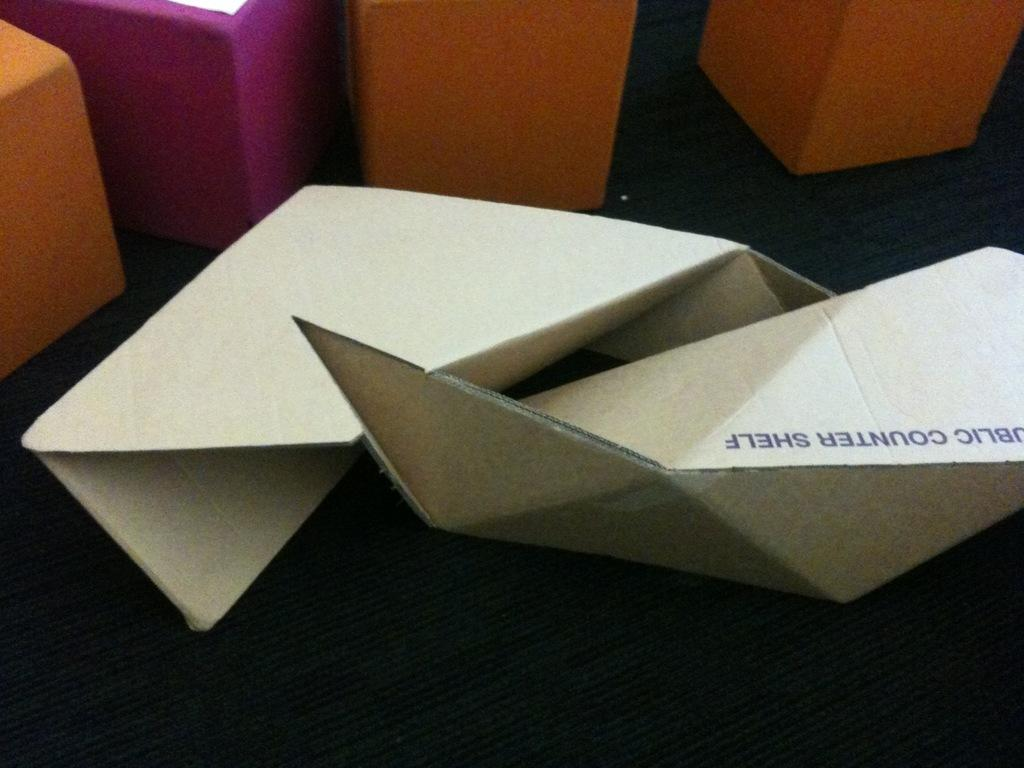What type of objects can be seen in the image? There are boxes and cardboard crafts in the image. Where are the objects located? The objects are on the floor. Can you describe the setting where the image might have been taken? The image may have been taken in a hall. What industry is depicted in the image? There is no specific industry depicted in the image; it shows boxes and cardboard crafts on the floor. 